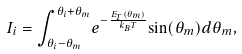<formula> <loc_0><loc_0><loc_500><loc_500>I _ { i } = { \int _ { { \theta _ { i } } - { \theta _ { m } } } ^ { { \theta _ { i } } + { \theta _ { m } } } } e ^ { - { \frac { E _ { T } { ( \theta _ { m } ) } } { k _ { B } T } } } { \sin ( \theta _ { m } ) } d { \theta _ { m } } ,</formula> 